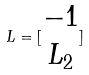Convert formula to latex. <formula><loc_0><loc_0><loc_500><loc_500>L = [ \begin{matrix} - 1 \\ L _ { 2 } \end{matrix} ]</formula> 